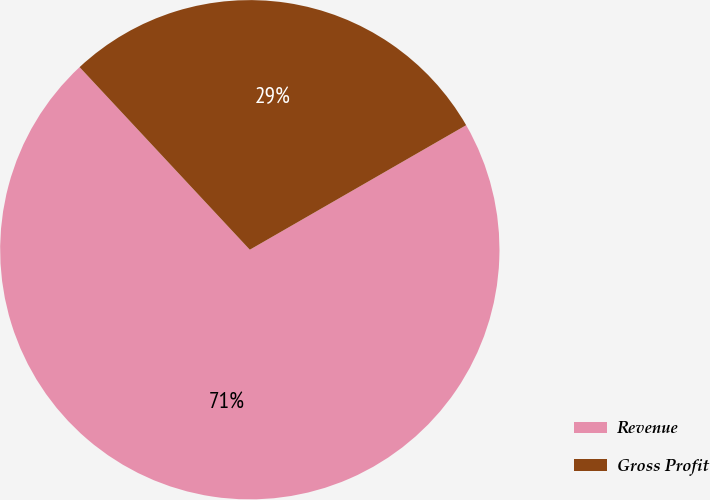Convert chart to OTSL. <chart><loc_0><loc_0><loc_500><loc_500><pie_chart><fcel>Revenue<fcel>Gross Profit<nl><fcel>71.37%<fcel>28.63%<nl></chart> 